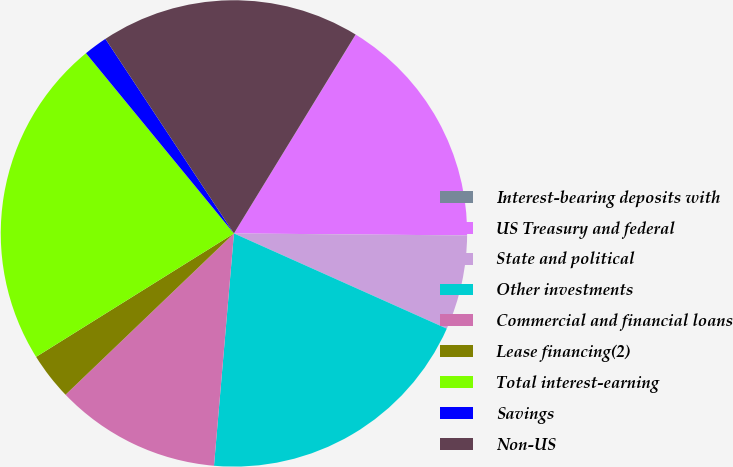Convert chart. <chart><loc_0><loc_0><loc_500><loc_500><pie_chart><fcel>Interest-bearing deposits with<fcel>US Treasury and federal<fcel>State and political<fcel>Other investments<fcel>Commercial and financial loans<fcel>Lease financing(2)<fcel>Total interest-earning<fcel>Savings<fcel>Non-US<nl><fcel>0.01%<fcel>16.39%<fcel>6.56%<fcel>19.67%<fcel>11.48%<fcel>3.28%<fcel>22.94%<fcel>1.65%<fcel>18.03%<nl></chart> 